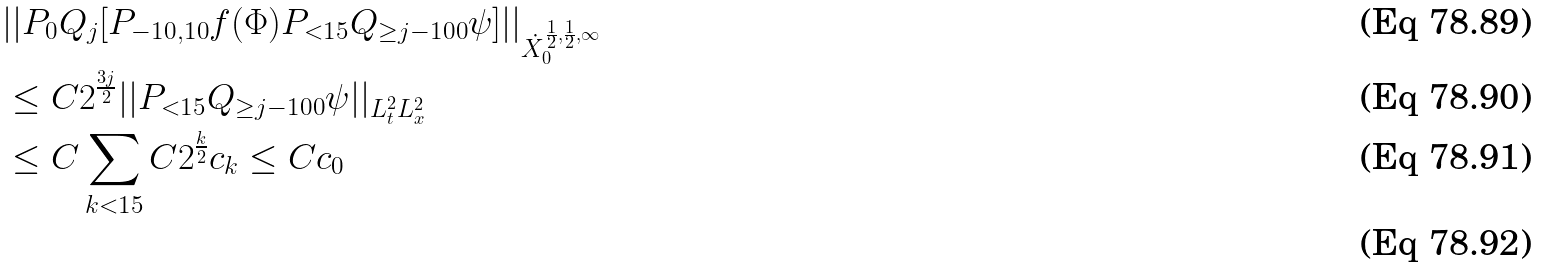Convert formula to latex. <formula><loc_0><loc_0><loc_500><loc_500>& | | P _ { 0 } Q _ { j } [ P _ { - 1 0 , 1 0 } f ( \Phi ) P _ { < 1 5 } Q _ { \geq j - 1 0 0 } \psi ] | | _ { \dot { X } _ { 0 } ^ { \frac { 1 } { 2 } , \frac { 1 } { 2 } , \infty } } \\ & \leq C 2 ^ { \frac { 3 j } { 2 } } | | P _ { < 1 5 } Q _ { \geq j - 1 0 0 } \psi | | _ { L _ { t } ^ { 2 } L _ { x } ^ { 2 } } \\ & \leq C \sum _ { k < 1 5 } C 2 ^ { \frac { k } { 2 } } c _ { k } \leq C c _ { 0 } \\</formula> 